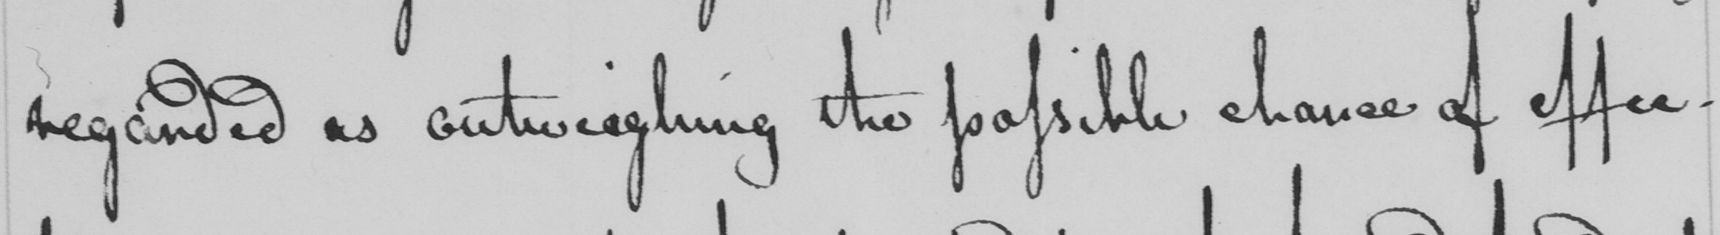What is written in this line of handwriting? regarded as outweighing the possible chance of effec 